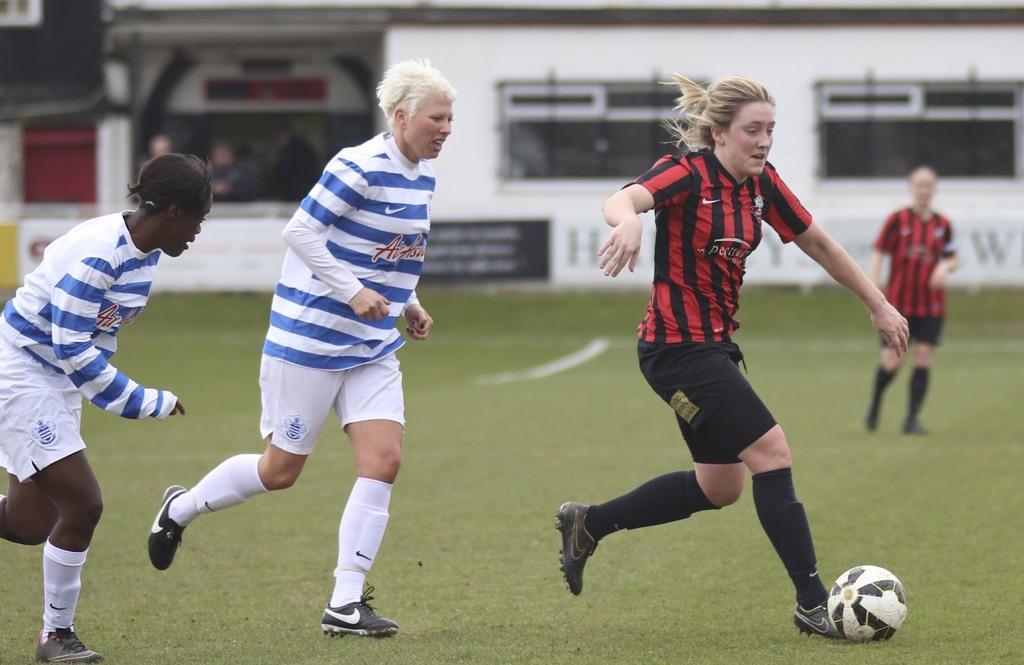In one or two sentences, can you explain what this image depicts? In this image there are a few players playing on the ground and there is a ball, in the background there is a building and there are two people standing. 